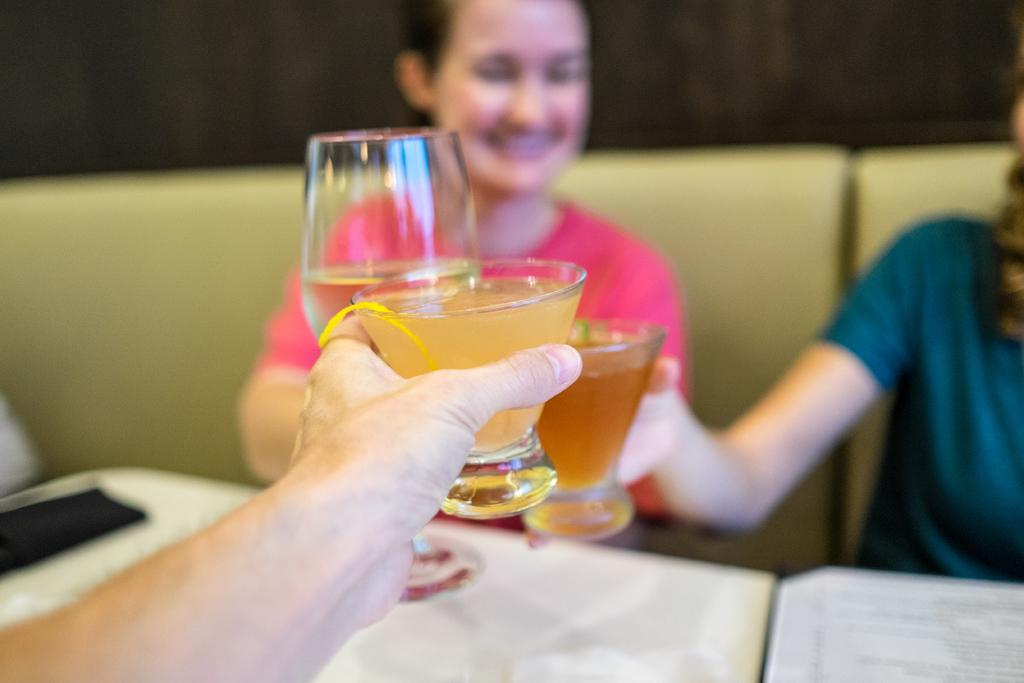What are the people in the image doing? The people in the image are sitting on a couch. What is in front of the couch? There is a table in front of the couch. What are the people holding in their hands? The people are holding glasses. What type of tongue can be seen sticking out of the glass in the image? There is no tongue visible in the image; the people are holding glasses, but there is no indication of a tongue sticking out of any of the glasses. 